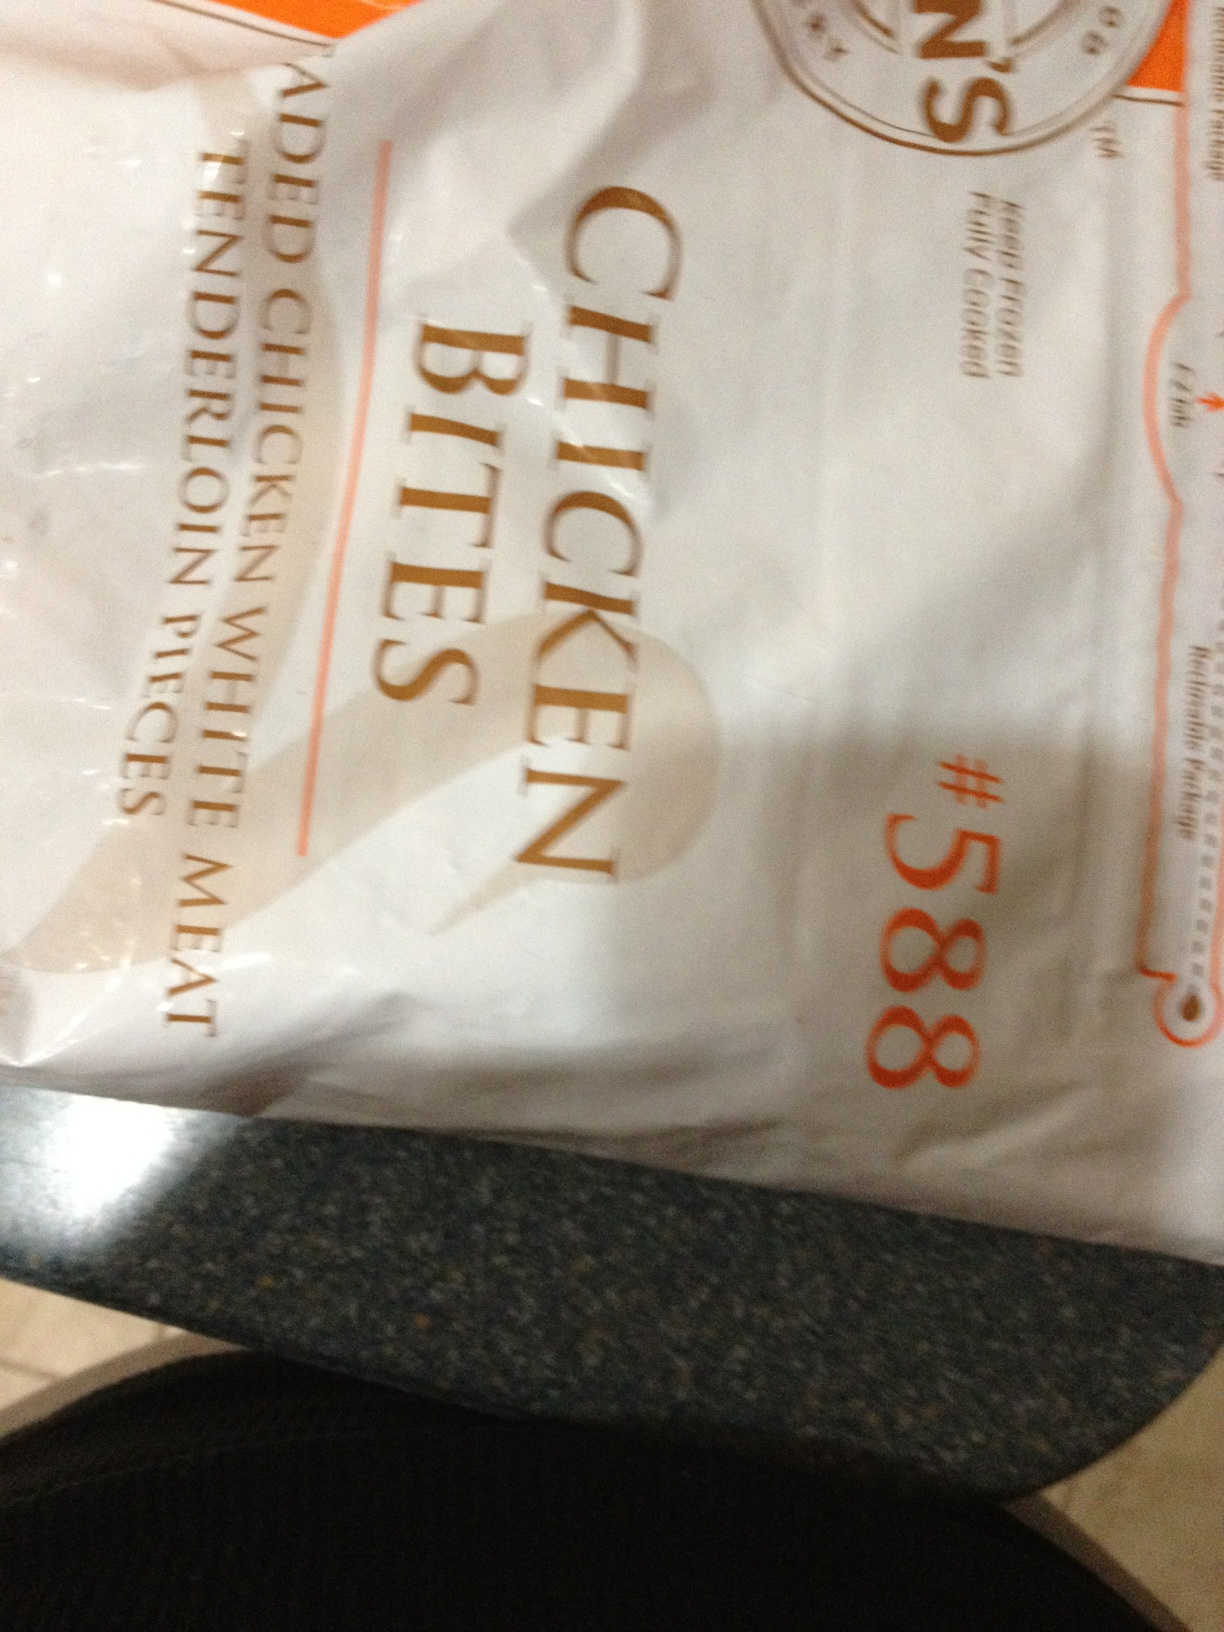What type of meal or dish are chicken bites typically used in? Chicken bites like these are generally used in quick snack preparations or as a part of meals like chicken salads, wraps, or can even be enjoyed with dips as an appetizer. Their versatile nature makes them a popular choice for various recipes. 